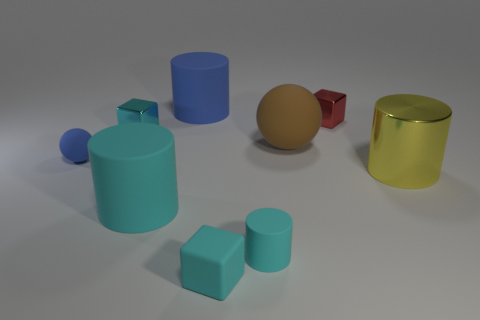Is there a small thing of the same color as the tiny rubber cylinder?
Ensure brevity in your answer.  Yes. The matte block that is the same size as the blue matte sphere is what color?
Provide a succinct answer. Cyan. Does the small cylinder have the same color as the cube that is in front of the large shiny thing?
Make the answer very short. Yes. What color is the small matte cube?
Keep it short and to the point. Cyan. What material is the small cyan cube in front of the big cyan object?
Your answer should be compact. Rubber. There is a cyan matte object that is the same shape as the red thing; what is its size?
Your answer should be very brief. Small. Are there fewer cyan objects behind the big brown rubber thing than small cyan blocks?
Offer a terse response. Yes. Are there any brown cylinders?
Your answer should be very brief. No. There is another small metal thing that is the same shape as the small red thing; what is its color?
Keep it short and to the point. Cyan. There is a large rubber cylinder that is in front of the blue matte cylinder; is it the same color as the tiny cylinder?
Keep it short and to the point. Yes. 